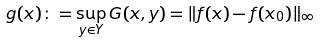Convert formula to latex. <formula><loc_0><loc_0><loc_500><loc_500>g ( x ) \colon = \sup _ { y \in Y } G ( x , y ) = \| f ( x ) - f ( x _ { 0 } ) \| _ { \infty }</formula> 